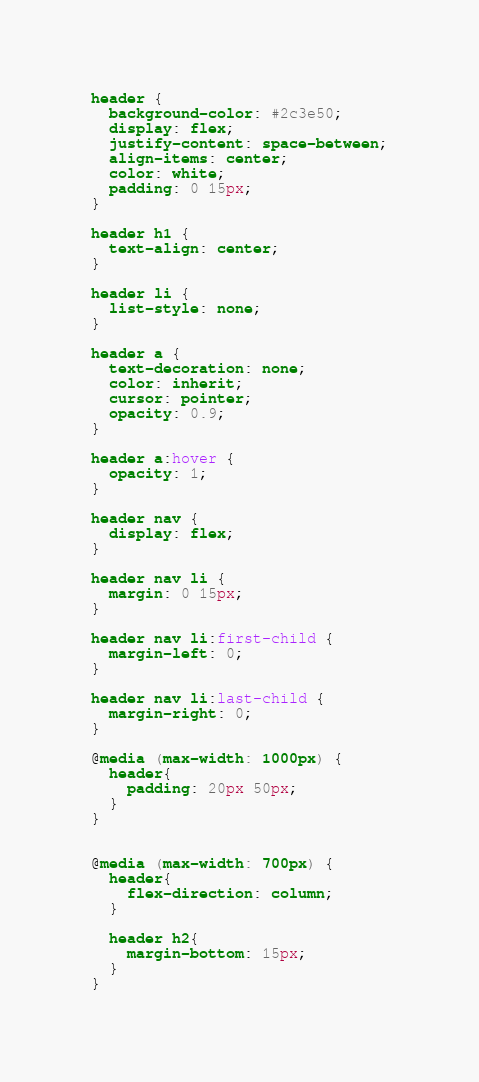<code> <loc_0><loc_0><loc_500><loc_500><_CSS_>header {
  background-color: #2c3e50;
  display: flex;
  justify-content: space-between;
  align-items: center;
  color: white;
  padding: 0 15px;
}

header h1 {
  text-align: center;
}

header li {
  list-style: none;
}

header a {
  text-decoration: none;
  color: inherit;
  cursor: pointer;
  opacity: 0.9;
}

header a:hover {
  opacity: 1;
}

header nav {
  display: flex;
}

header nav li {
  margin: 0 15px;
}

header nav li:first-child {
  margin-left: 0;
}

header nav li:last-child {
  margin-right: 0;
}

@media (max-width: 1000px) {
  header{
    padding: 20px 50px;
  }
}


@media (max-width: 700px) {
  header{
    flex-direction: column;
  }

  header h2{
    margin-bottom: 15px;
  }
}</code> 